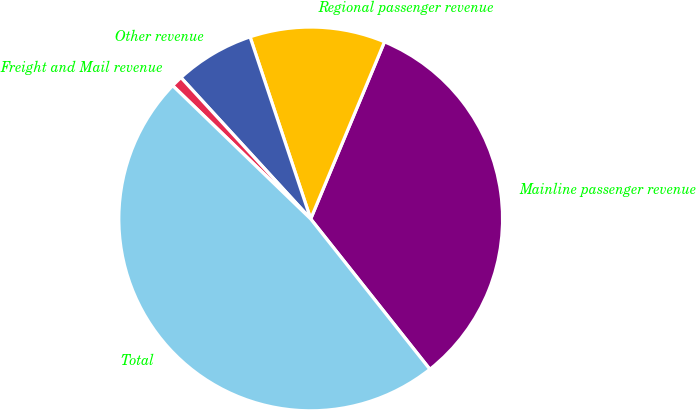Convert chart to OTSL. <chart><loc_0><loc_0><loc_500><loc_500><pie_chart><fcel>Mainline passenger revenue<fcel>Regional passenger revenue<fcel>Other revenue<fcel>Freight and Mail revenue<fcel>Total<nl><fcel>33.05%<fcel>11.4%<fcel>6.7%<fcel>0.96%<fcel>47.89%<nl></chart> 